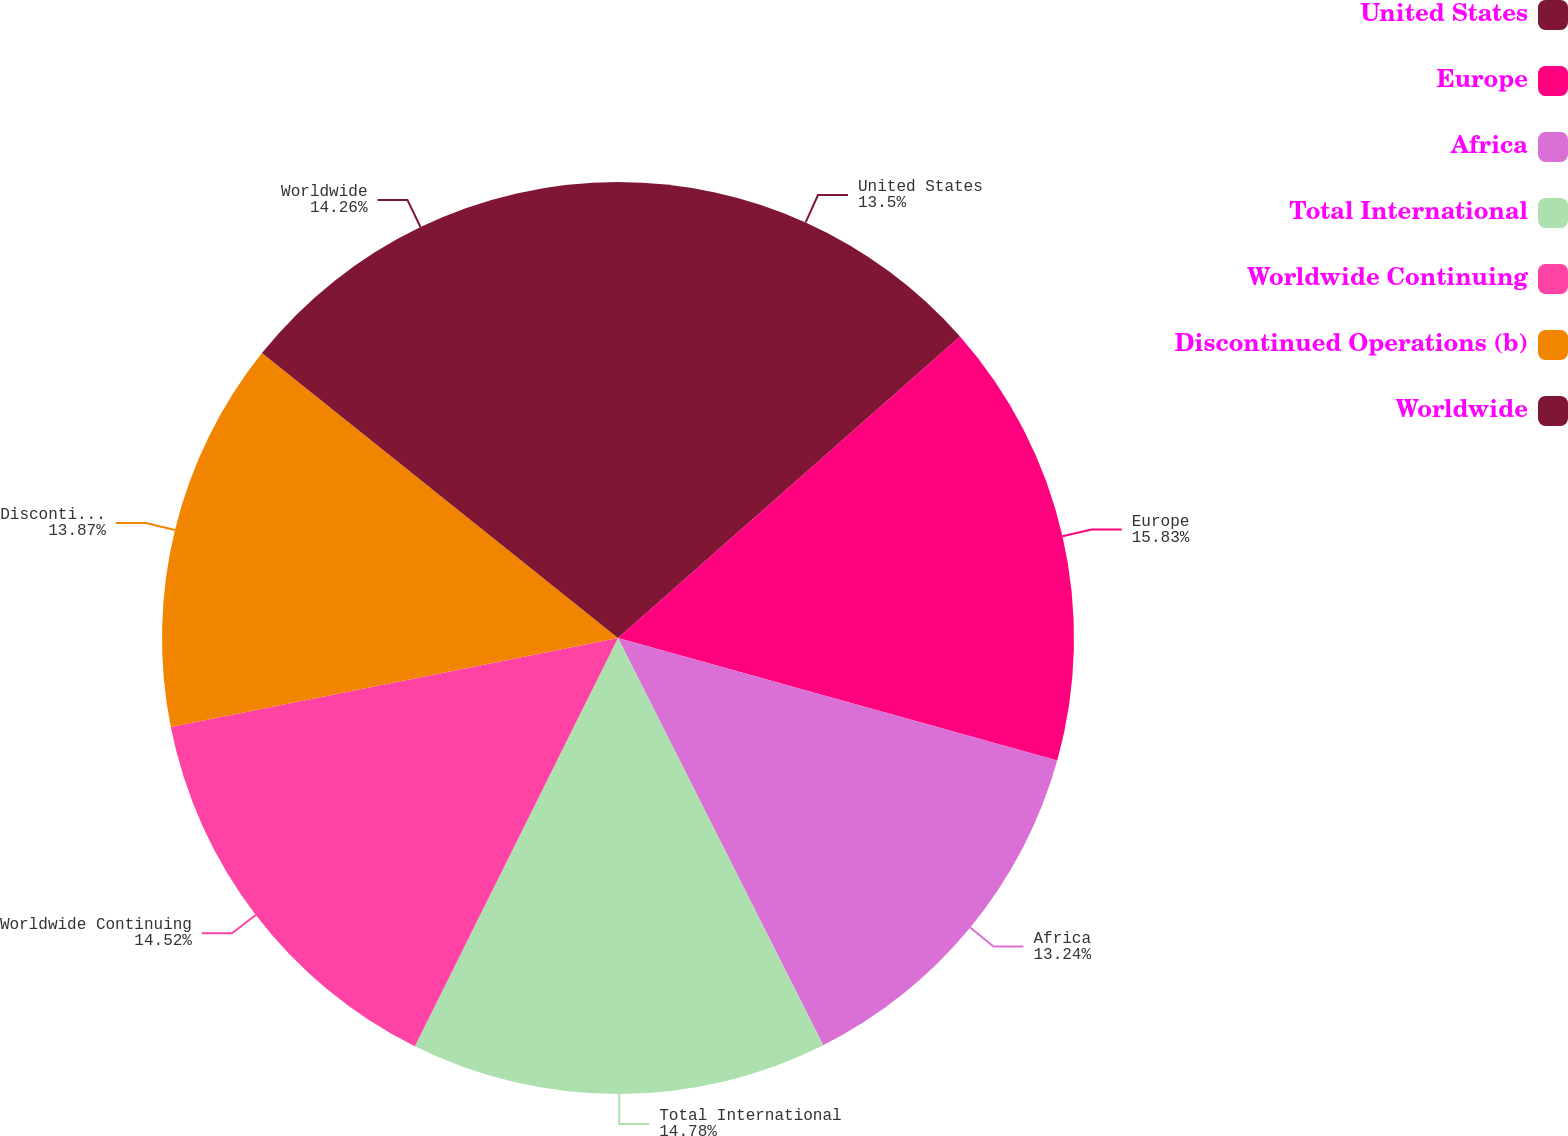Convert chart. <chart><loc_0><loc_0><loc_500><loc_500><pie_chart><fcel>United States<fcel>Europe<fcel>Africa<fcel>Total International<fcel>Worldwide Continuing<fcel>Discontinued Operations (b)<fcel>Worldwide<nl><fcel>13.5%<fcel>15.83%<fcel>13.24%<fcel>14.78%<fcel>14.52%<fcel>13.87%<fcel>14.26%<nl></chart> 